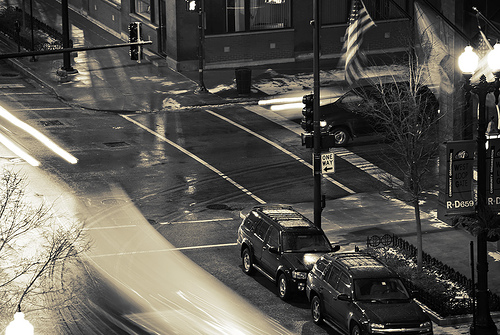Please identify all text content in this image. R.D859 R-D ONE WAY 